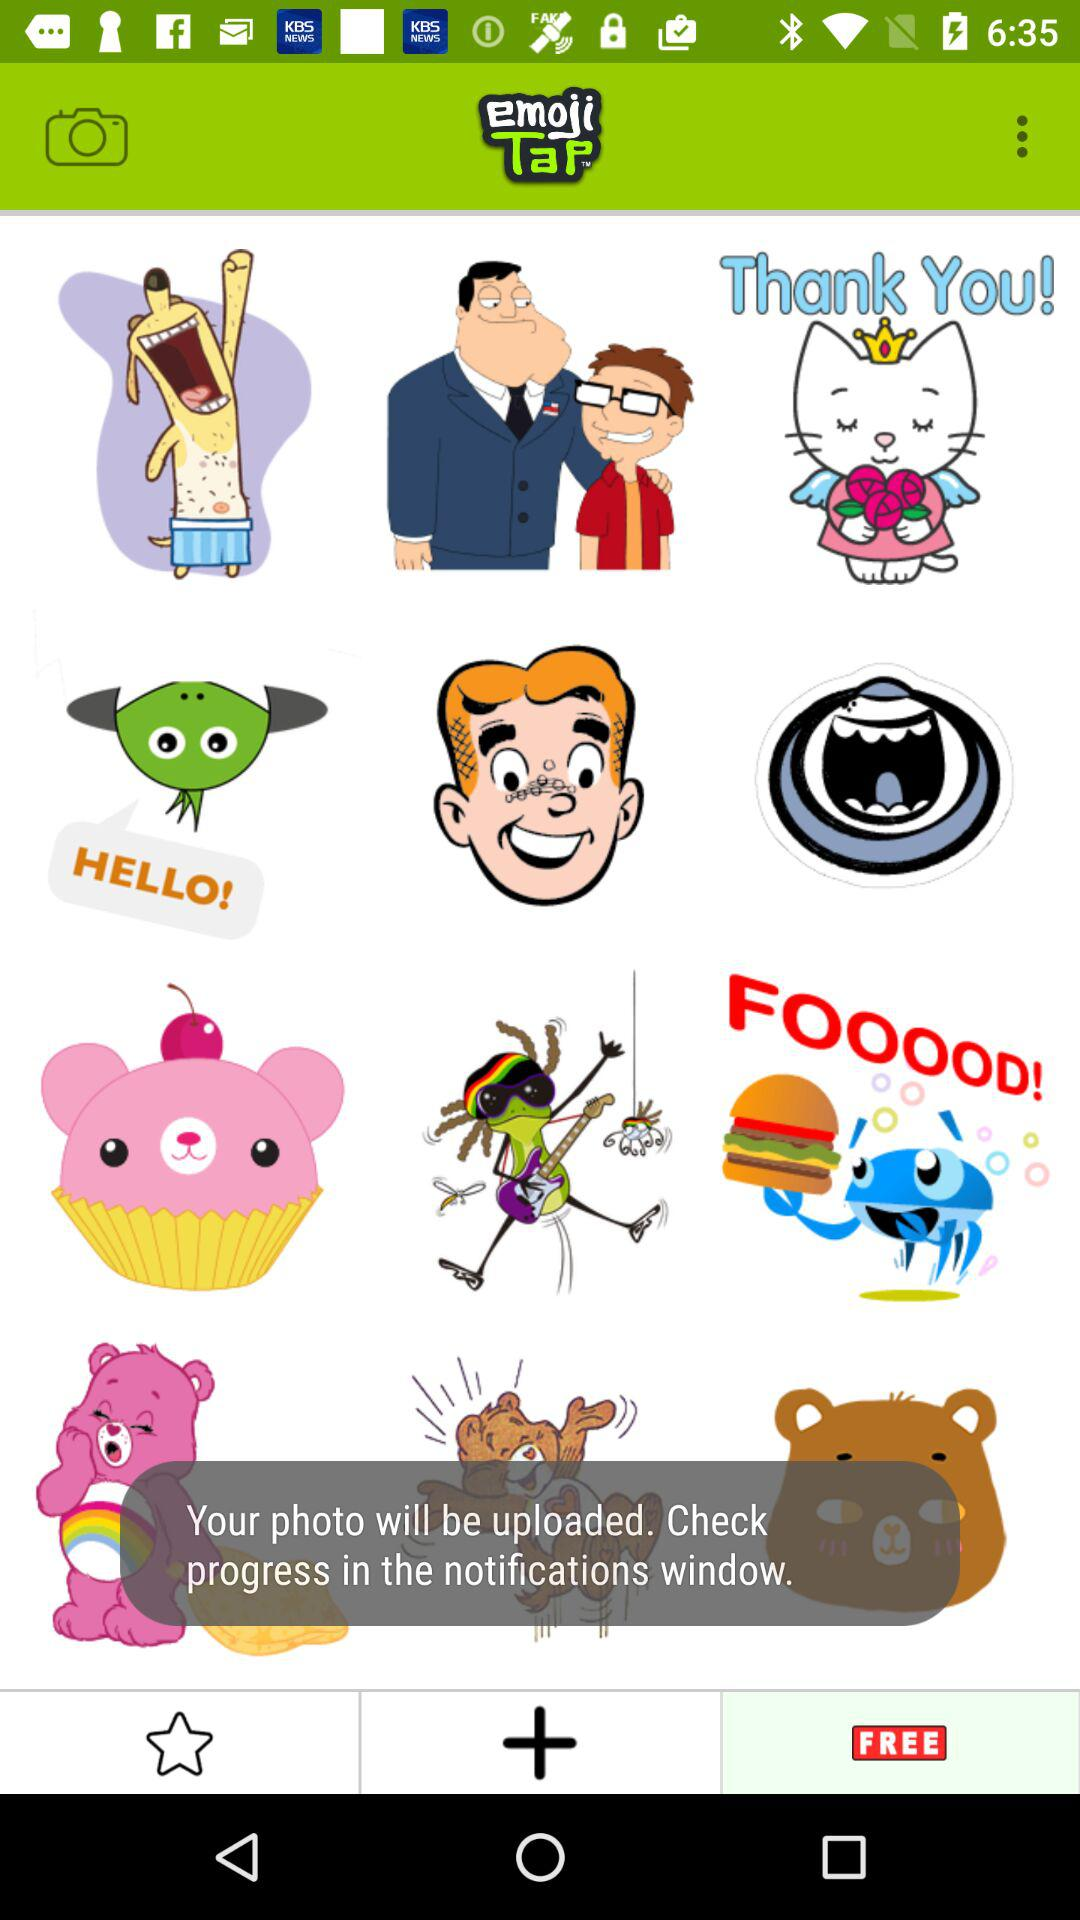What is the name of the application? The name of the application is "emojiTap". 